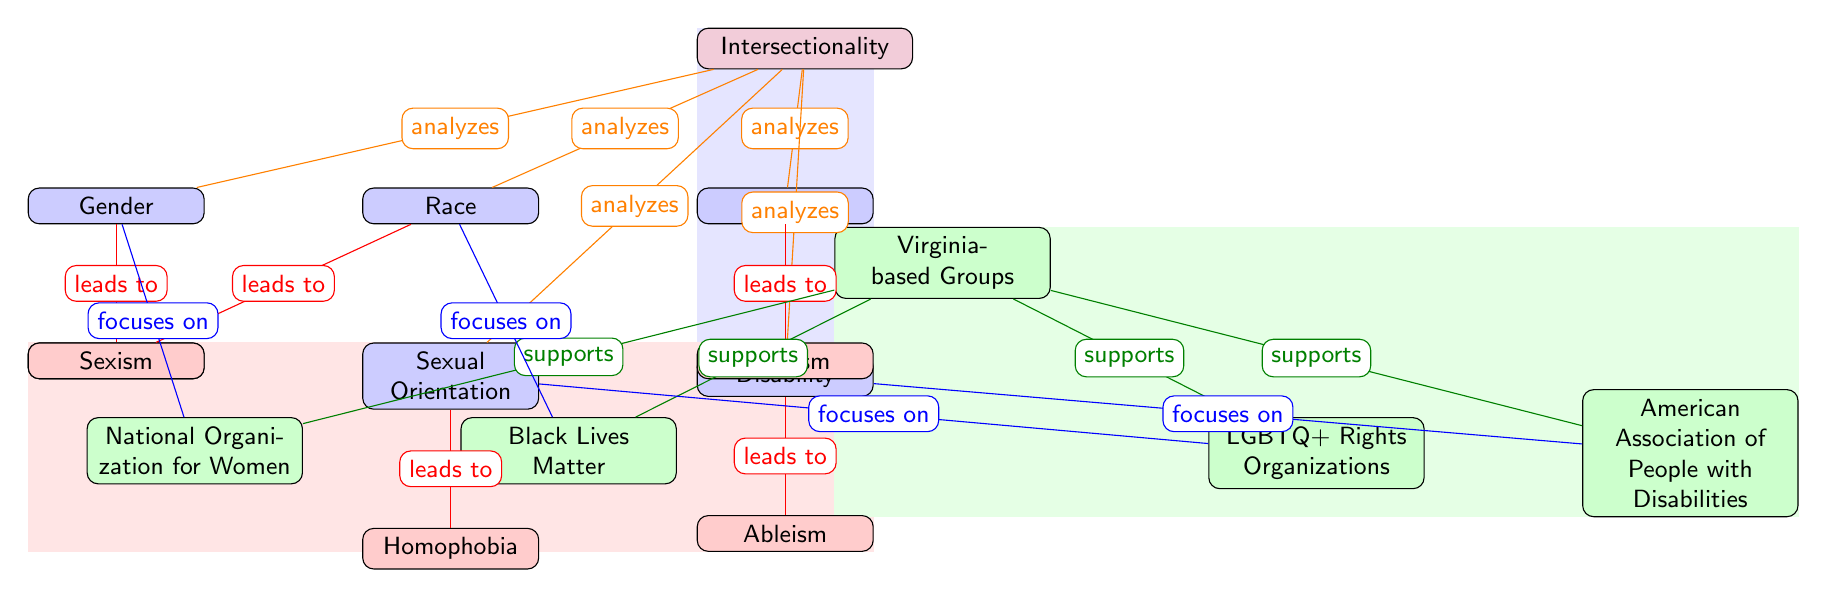What is the central concept of the diagram? The diagram's central concept is located at the top where it states "Intersectionality", indicating that all relationships in the diagram revolve around this idea.
Answer: Intersectionality How many social identities are represented in the diagram? There are five social identities represented: Race, Gender, Class, Sexual Orientation, and Disability. Counting these nodes gives a total of five.
Answer: 5 Which form of oppression is associated with Gender? The diagram shows a direct link from Gender to its corresponding oppression, which is labeled as "Sexism". This indicates that sexism is the oppression related to gender.
Answer: Sexism What do the Virginia-based groups primarily support? The diagram indicates connections from "Virginia-based Groups" to various organizations, each supporting different social identities, but it ultimately shows that they collectively support the central concept of intersectionality.
Answer: Intersectionality Which organization focuses on Sexual Orientation? The diagram has a direct link from LGBTQ+ Rights Organizations to Sexual Orientation, denoting that it specifically focuses on this identity.
Answer: LGBTQ+ Rights Organizations Which two forms of oppression overlap with Race? The diagram shows that Race leads to two forms of oppression: "Racism" and "Sexism". These two oppressions are directly tied to the identity of race as illustrated in the connections.
Answer: Racism, Sexism Which organization is focused on Disability issues? The diagram links the American Association of People with Disabilities directly to the identity of Disability, indicating that this organization specifically deals with issues related to disability.
Answer: American Association of People with Disabilities What is the relationship between Black Lives Matter and Race? The diagram specifies a direct connection from Black Lives Matter to Race, indicating that this organization has a focus on racial issues, which is clearly depicted in the flow of the diagram.
Answer: focuses on How many types of oppression are identified in the diagram? By examining the elements of oppression in the diagram, we find five distinct types directly listed: Racism, Sexism, Classism, Homophobia, and Ableism. Thus, there are five types of oppression represented.
Answer: 5 